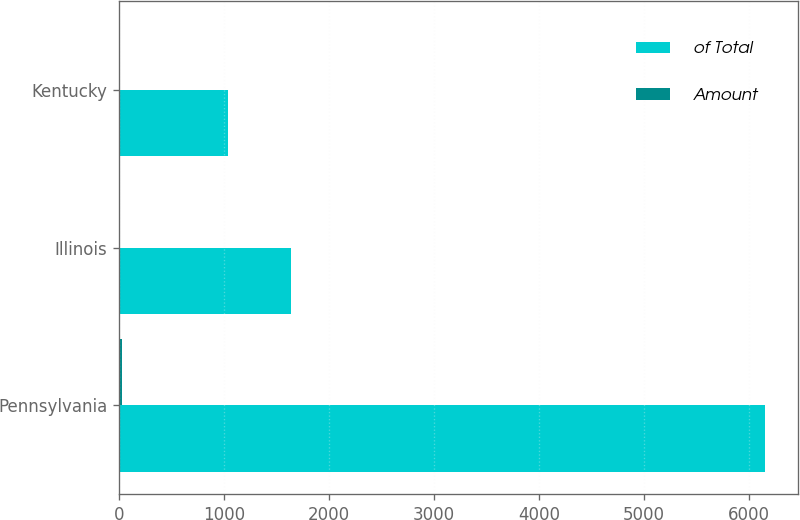Convert chart to OTSL. <chart><loc_0><loc_0><loc_500><loc_500><stacked_bar_chart><ecel><fcel>Pennsylvania<fcel>Illinois<fcel>Kentucky<nl><fcel>of Total<fcel>6160<fcel>1634<fcel>1040<nl><fcel>Amount<fcel>24<fcel>6<fcel>4<nl></chart> 